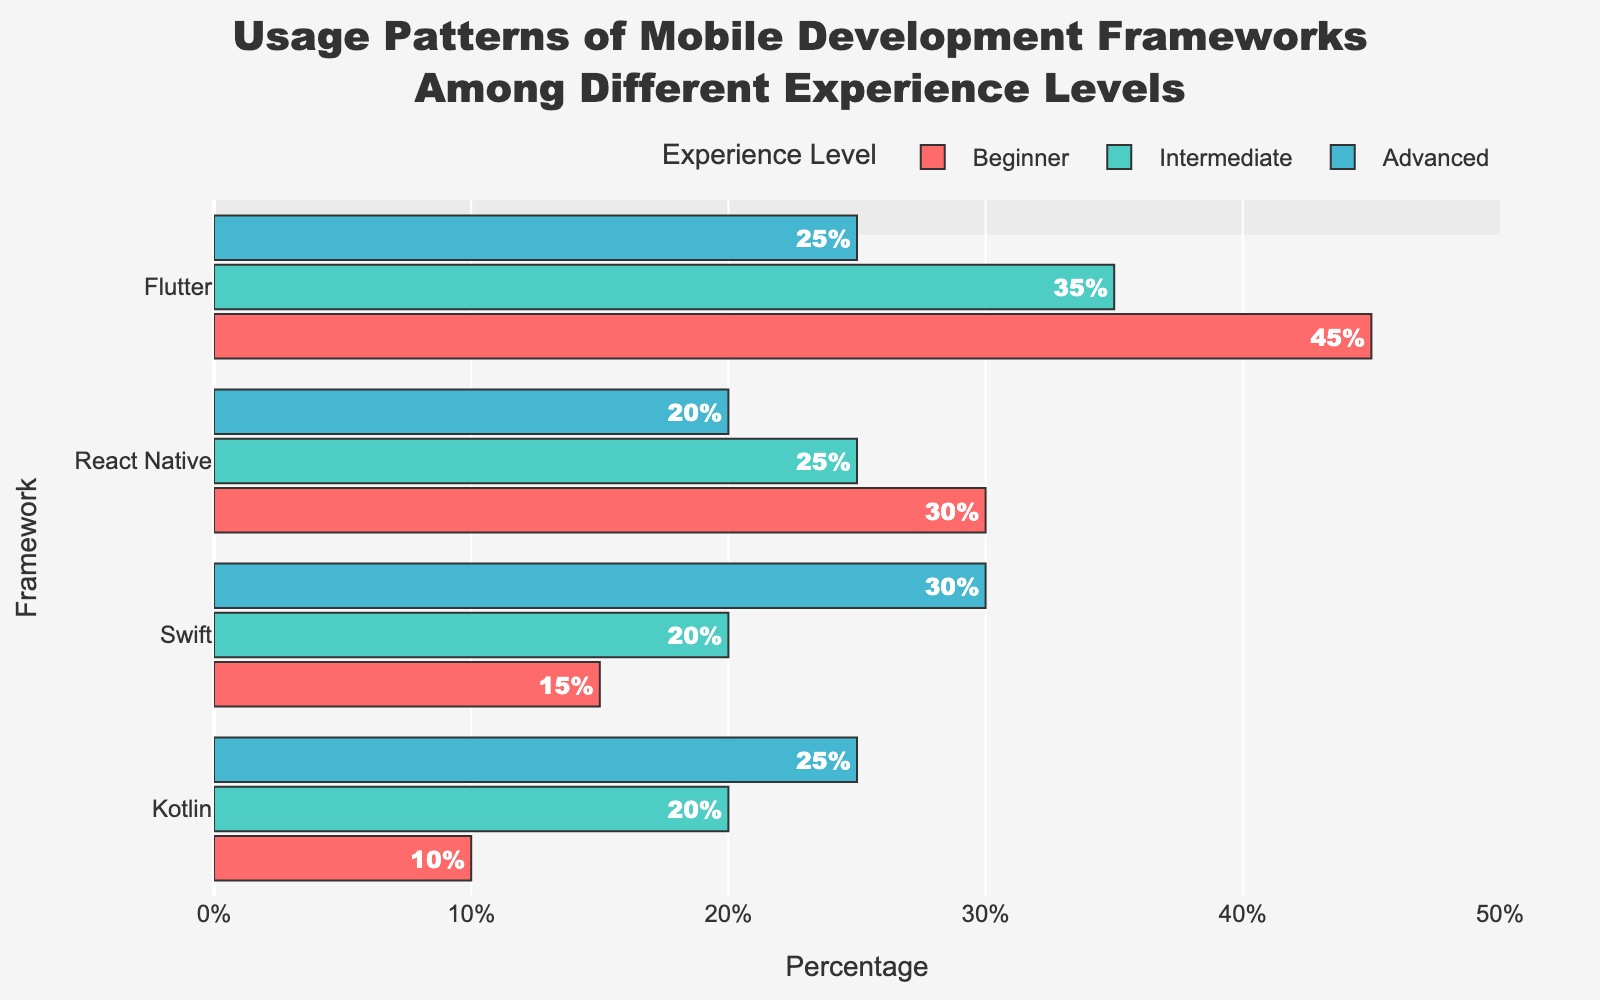Which framework has the highest usage among beginners? To answer this question, look at the lengths of the bars representing different frameworks for the 'Beginner' group. The longest bar represents the framework with the highest usage. In the figure, Flutter has the longest bar among beginners.
Answer: Flutter Which framework has the lowest usage among advanced developers? Observe the bars in the 'Advanced' group. The framework with the shortest bar indicates the lowest usage among advanced developers. From the figure, React Native has the shortest bar.
Answer: React Native What is the difference in React Native usage between Beginners and Advanced developers? To answer, subtract the percentage of Advanced developers using React Native from the percentage of Beginner developers using React Native. From the figure, the percentages are 30% for Beginners and 20% for Advanced, so the difference is 30% - 20%.
Answer: 10% Which experience level has the most balanced usage across all frameworks? Look at the bars for each experience level and see which group has the least variation in bar lengths. The Intermediate group has relatively balanced bar lengths compared to Beginners and Advanced.
Answer: Intermediate How does the usage of Swift compare between Beginners and Intermediate developers? Compare the bar lengths for Swift under the Beginner and Intermediate groups. Beginners have a shorter bar (15%) than Intermediate developers (20%).
Answer: Intermediate developers use Swift more What is the sum of the percentages for Kotlin across all experience levels? Add the percentages for Kotlin usage across all groups. The values are 10% (Beginner) + 20% (Intermediate) + 25% (Advanced).
Answer: 55% Which framework's usage increases with experience and which decreases? Examine the trends in bar lengths from Beginners to Advanced for each framework. Swift's usage increases (15% to 30%), while React Native's usage decreases (30% to 20%).
Answer: Swift increases, React Native decreases For Flutter, what is the difference in usage between Intermediate and Advanced developers? Subtract the percentage of Advanced developers using Flutter from the percentage of Intermediate developers using Flutter. From the figure, the percentages are 35% for Intermediate and 25% for Advanced.
Answer: 10% Which framework has the highest overall usage across all experience levels? Sum the usage percentages for each framework across all groups and compare. Flutter has high values of 45% (Beginner) + 35% (Intermediate) + 25% (Advanced).
Answer: Flutter If we consider only the Intermediate group, which two frameworks have equal usage? Look at the Intermediate group and compare the bar lengths. Swift and Kotlin both have bars at 20%.
Answer: Swift and Kotlin 